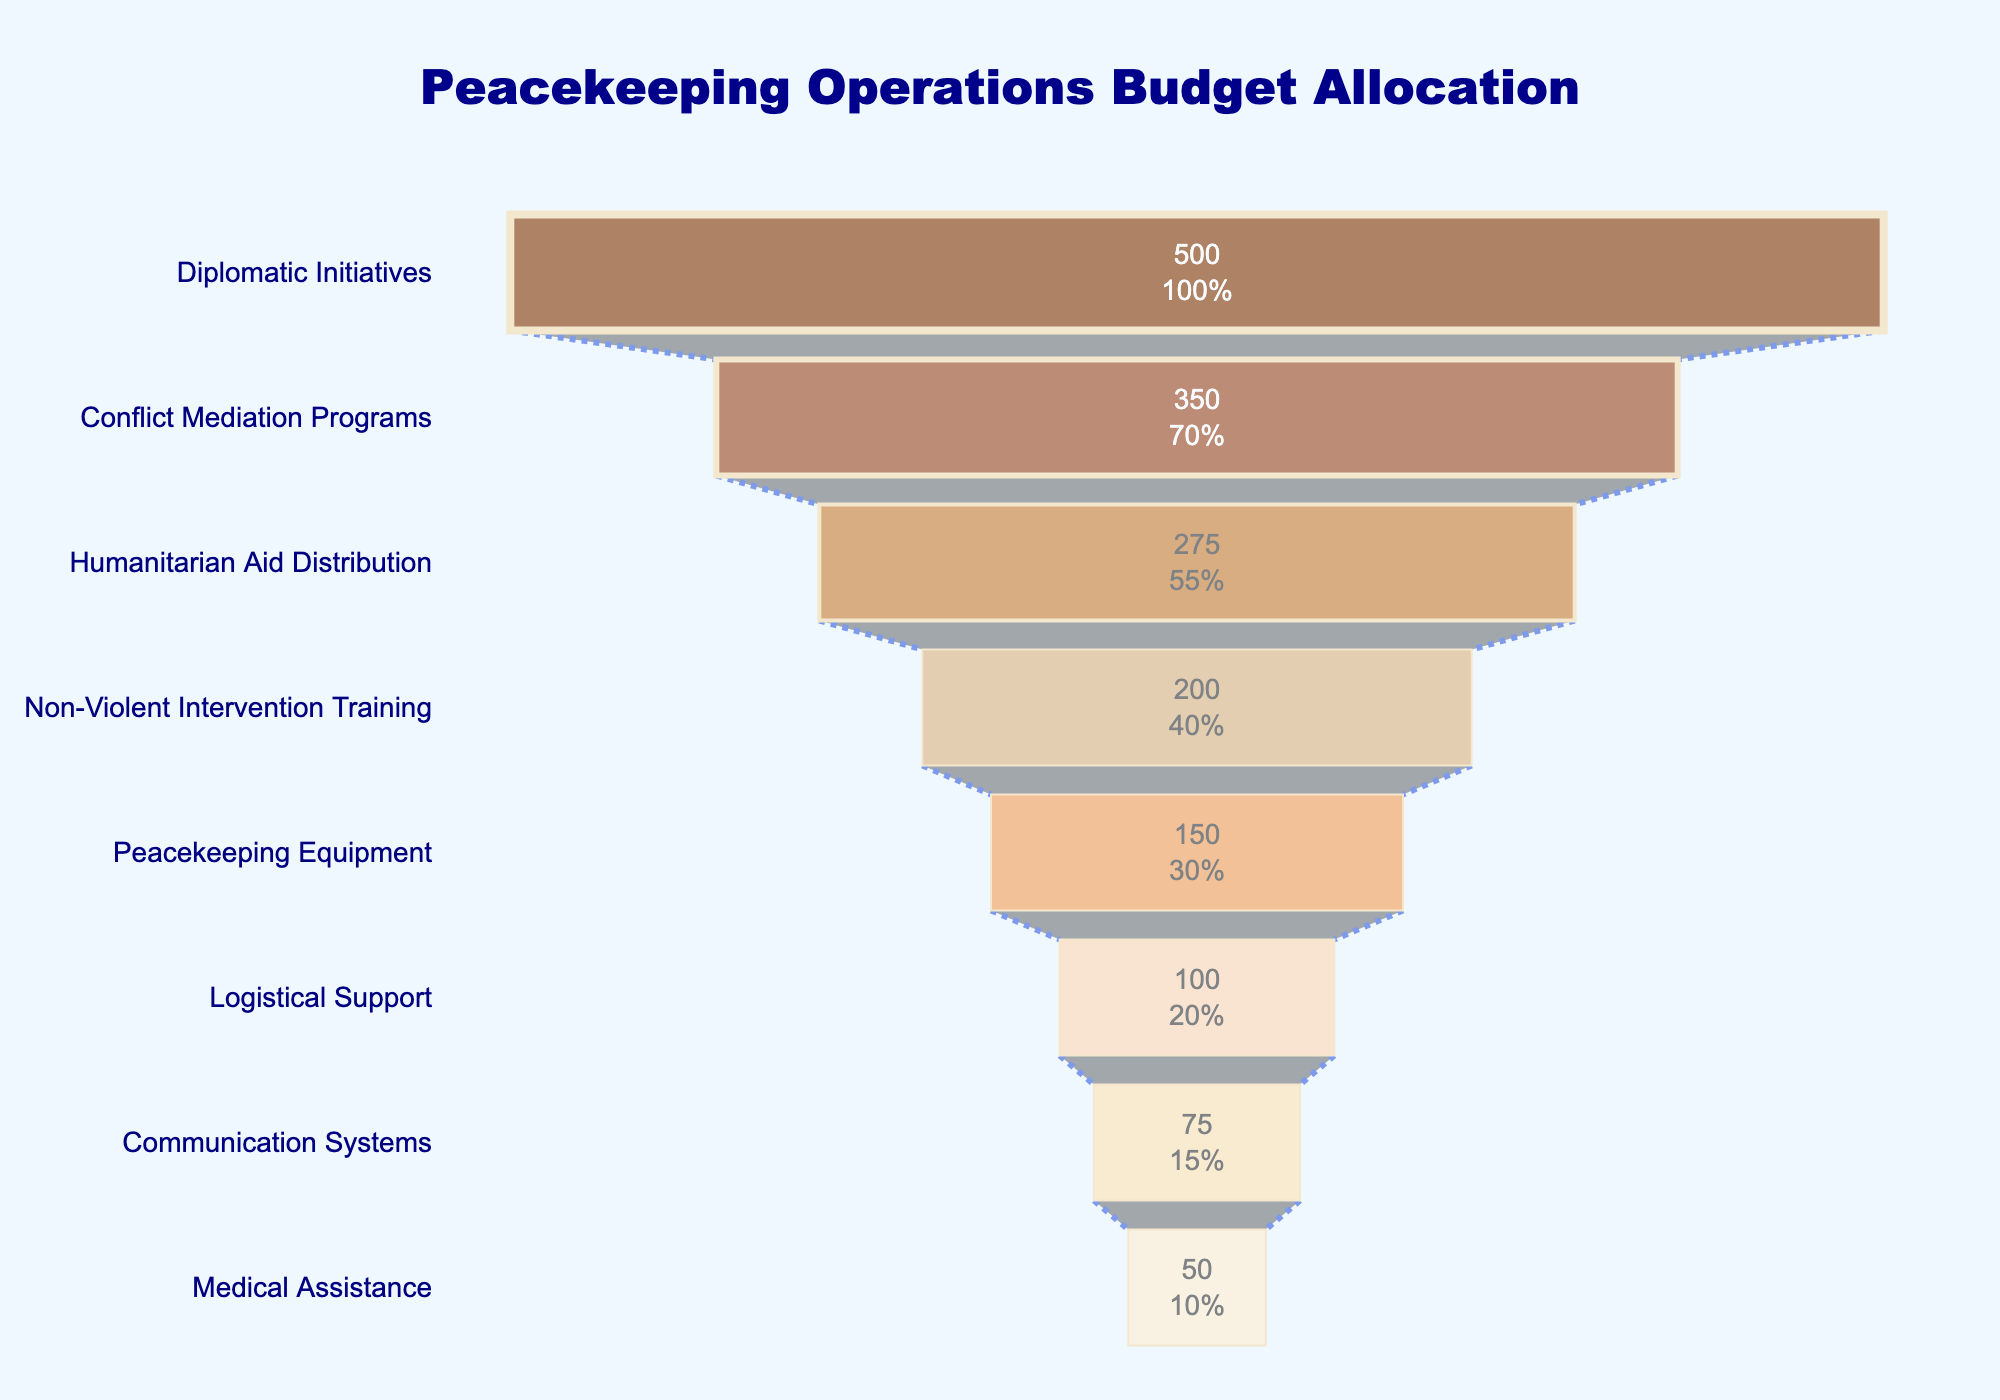What's the title of the chart? The title of the chart is prominently displayed at the top.
Answer: Peacekeeping Operations Budget Allocation How much budget is allocated to Diplomatic Initiatives? Look at the bar labeled 'Diplomatic Initiatives'. The value is shown inside the bar.
Answer: 500 million USD Which category has the lowest budget allocation? Identify the shortest and lowest value bar in the funnel chart.
Answer: Medical Assistance How much more is spent on Diplomatic Initiatives than on Non-Violent Intervention Training? Find the value for Diplomatic Initiatives (500 million USD) and Non-Violent Intervention Training (200 million USD). Subtract the latter from the former.
Answer: 300 million USD What percentage of the initial budget is allocated to Conflict Mediation Programs? Look at the percentage displayed inside the 'Conflict Mediation Programs' section.
Answer: 35% How many categories have budget allocations greater than 100 million USD? Count all the bars with values higher than 100 million USD.
Answer: Five What is the combined budget allocation for Humanitarian Aid Distribution and Logistical Support? Find the values for Humanitarian Aid Distribution (275 million USD) and Logistical Support (100 million USD). Add them together.
Answer: 375 million USD Which category has the second largest budget allocation? Identify the second longest bar in the funnel chart.
Answer: Conflict Mediation Programs How much less is allocated to Peacekeeping Equipment than to Humanitarian Aid Distribution? Find the values for Peacekeeping Equipment (150 million USD) and Humanitarian Aid Distribution (275 million USD). Subtract the former from the latter.
Answer: 125 million USD Which categories have budget allocations between 50 and 200 million USD? Identify and list the bars with values within the specified range.
Answer: Non-Violent Intervention Training, Peacekeeping Equipment, Logistical Support, Communication Systems, Medical Assistance 